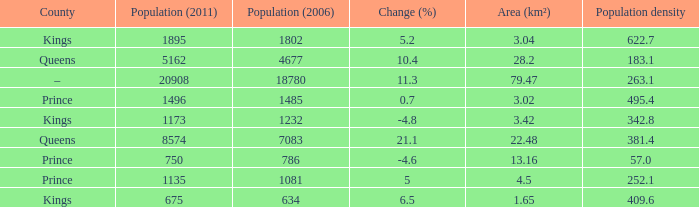In the County of Prince, what was the highest Population density when the Area (km²) was larger than 3.02, and the Population (2006) was larger than 786, and the Population (2011) was smaller than 1135? None. 